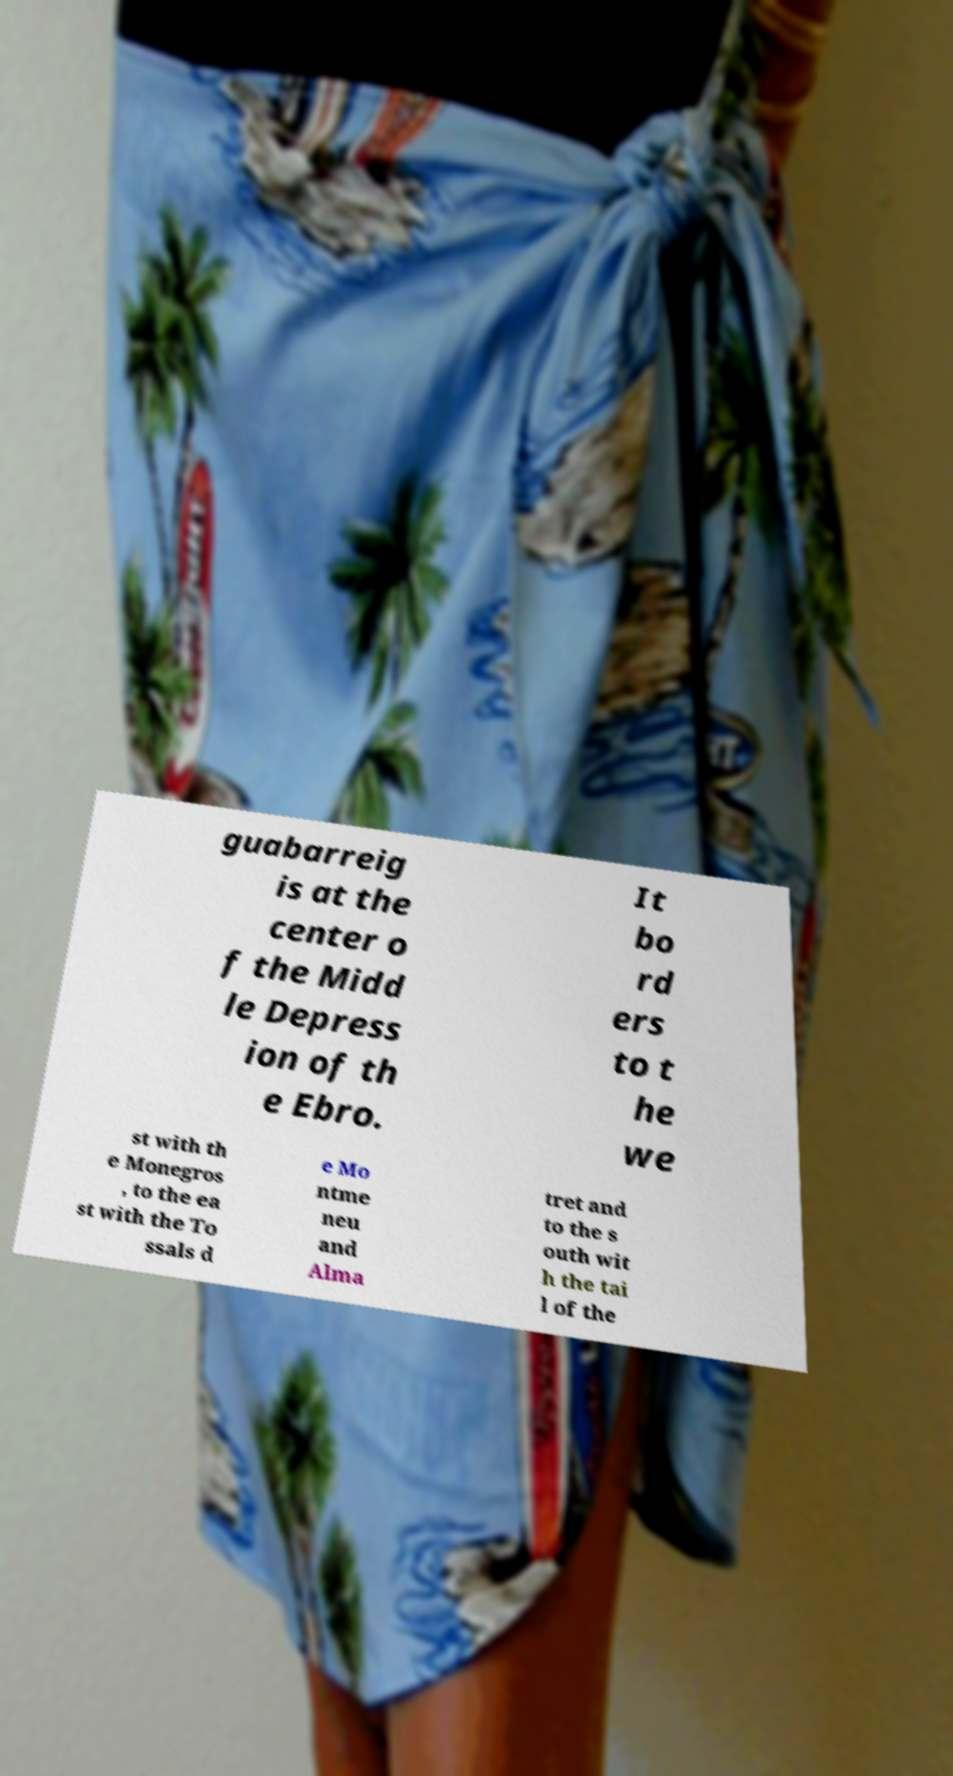Could you extract and type out the text from this image? guabarreig is at the center o f the Midd le Depress ion of th e Ebro. It bo rd ers to t he we st with th e Monegros , to the ea st with the To ssals d e Mo ntme neu and Alma tret and to the s outh wit h the tai l of the 